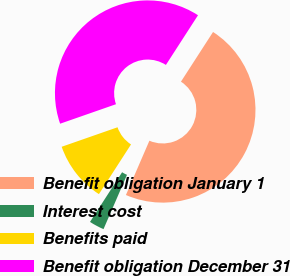Convert chart to OTSL. <chart><loc_0><loc_0><loc_500><loc_500><pie_chart><fcel>Benefit obligation January 1<fcel>Interest cost<fcel>Benefits paid<fcel>Benefit obligation December 31<nl><fcel>47.37%<fcel>2.63%<fcel>10.53%<fcel>39.47%<nl></chart> 